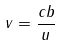<formula> <loc_0><loc_0><loc_500><loc_500>v = \frac { c b } { u }</formula> 